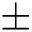Convert formula to latex. <formula><loc_0><loc_0><loc_500><loc_500>\pm</formula> 